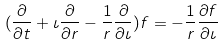<formula> <loc_0><loc_0><loc_500><loc_500>( \frac { \partial } { \partial t } + \iota \frac { \partial } { \partial r } - \frac { 1 } { r } \frac { \partial } { \partial \iota } ) f = - \frac { 1 } { r } \frac { \partial f } { \partial \iota }</formula> 